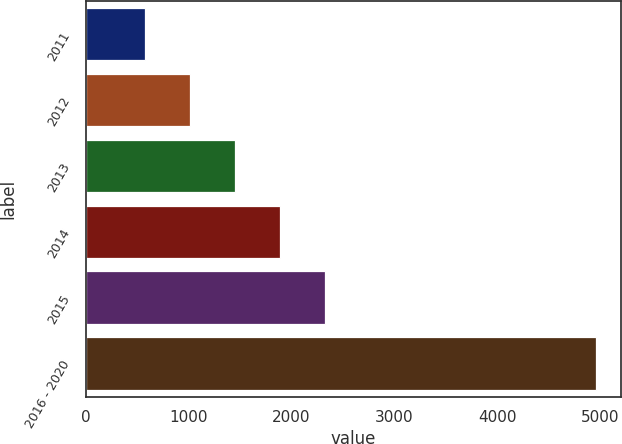Convert chart to OTSL. <chart><loc_0><loc_0><loc_500><loc_500><bar_chart><fcel>2011<fcel>2012<fcel>2013<fcel>2014<fcel>2015<fcel>2016 - 2020<nl><fcel>574<fcel>1012.5<fcel>1451<fcel>1889.5<fcel>2328<fcel>4959<nl></chart> 